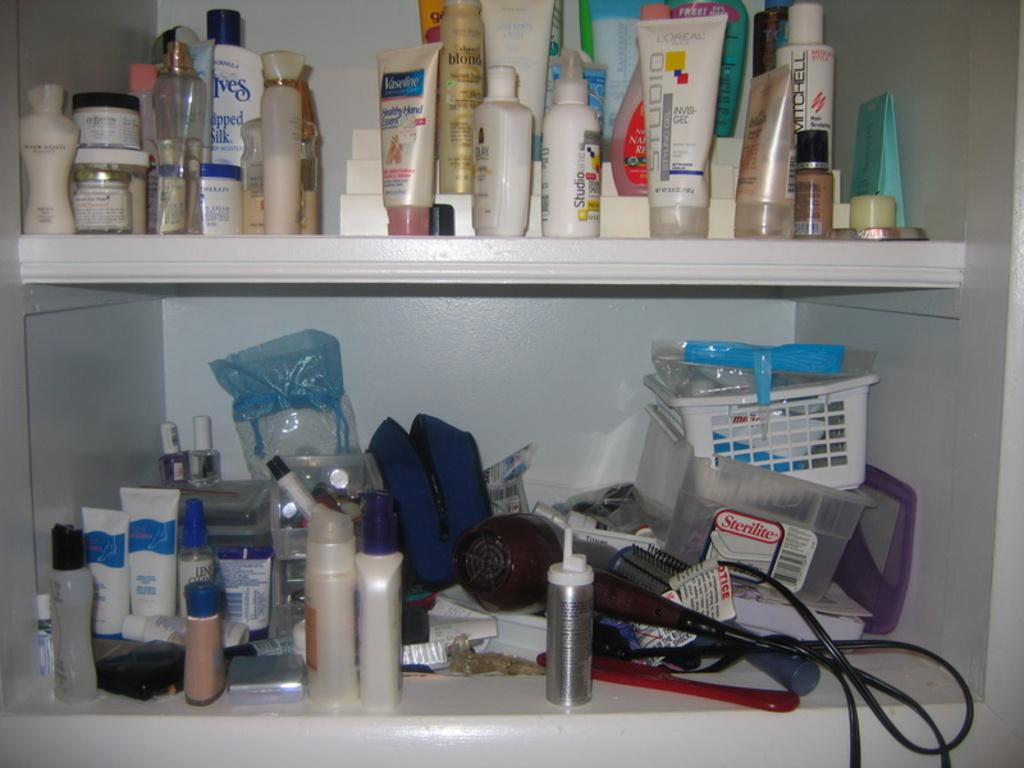Provide a one-sentence caption for the provided image. A bathroom pantry with a Sterilite container in it. 